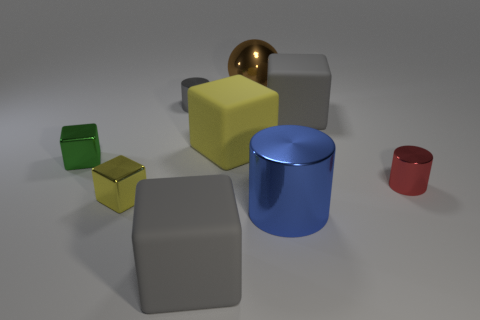Are there more tiny yellow cylinders than large yellow matte things?
Make the answer very short. No. Is there a tiny rubber block?
Make the answer very short. No. What shape is the big gray rubber object that is in front of the gray matte thing that is behind the large yellow block?
Your response must be concise. Cube. How many things are either tiny blue matte spheres or small metallic objects that are in front of the gray cylinder?
Keep it short and to the point. 3. There is a cylinder that is behind the gray rubber cube to the right of the rubber thing that is in front of the tiny green thing; what color is it?
Ensure brevity in your answer.  Gray. There is a green object that is the same shape as the tiny yellow object; what is its material?
Provide a short and direct response. Metal. What color is the shiny ball?
Provide a short and direct response. Brown. How many matte objects are big blue cylinders or blocks?
Your response must be concise. 3. There is a small shiny cylinder in front of the large gray cube behind the big yellow block; are there any small yellow cubes right of it?
Your response must be concise. No. What size is the green cube that is made of the same material as the brown ball?
Make the answer very short. Small. 